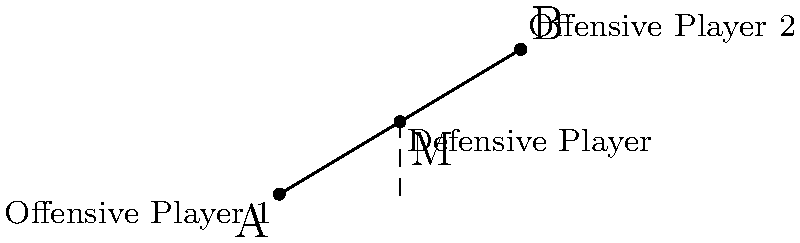In a crucial soccer match, two offensive players are positioned at coordinates A(0,0) and B(10,6). As a defensive strategist, you need to determine the optimal position for a defensive player to intercept potential passes between the two offensive threats. Using the midpoint formula, calculate the coordinates of the ideal defensive position M. How would this positioning strategy translate to digital media coverage of the game? To find the optimal position for the defensive player, we'll use the midpoint formula:

1) The midpoint formula is:
   $$ M = (\frac{x_1 + x_2}{2}, \frac{y_1 + y_2}{2}) $$

2) We have:
   A(0,0) and B(10,6)
   So, $x_1 = 0$, $y_1 = 0$, $x_2 = 10$, $y_2 = 6$

3) Plugging into the formula:
   $$ M = (\frac{0 + 10}{2}, \frac{0 + 6}{2}) = (5, 3) $$

4) Therefore, the optimal position for the defensive player is at coordinates (5,3).

This positioning strategy can be visualized and analyzed in real-time using digital media. Advanced analytics platforms could use this data to:
- Create heat maps showing optimal defensive positions
- Provide instant tactical analysis for viewers
- Generate predictive models for player movements and strategies

Such digital integration enhances viewer engagement and provides deeper insights into the game's strategic elements.
Answer: (5,3) 